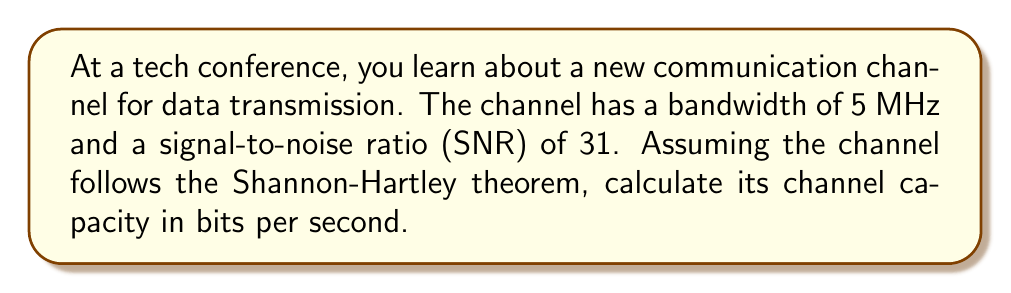Provide a solution to this math problem. To solve this problem, we'll use the Shannon-Hartley theorem, which gives the channel capacity for a noisy communication channel. The theorem states:

$$C = B \log_2(1 + SNR)$$

Where:
$C$ is the channel capacity in bits per second
$B$ is the bandwidth in Hz
$SNR$ is the signal-to-noise ratio (linear, not dB)

Given:
- Bandwidth, $B = 5$ MHz = $5 \times 10^6$ Hz
- SNR = 31 (linear scale)

Step 1: Plug the values into the Shannon-Hartley equation:

$$C = (5 \times 10^6) \log_2(1 + 31)$$

Step 2: Simplify the expression inside the logarithm:

$$C = (5 \times 10^6) \log_2(32)$$

Step 3: Calculate $\log_2(32)$:
$\log_2(32) = 5$ (since $2^5 = 32$)

Step 4: Multiply the result by the bandwidth:

$$C = (5 \times 10^6) \times 5 = 25 \times 10^6$$

Therefore, the channel capacity is 25 million bits per second or 25 Mbps.
Answer: 25 Mbps 